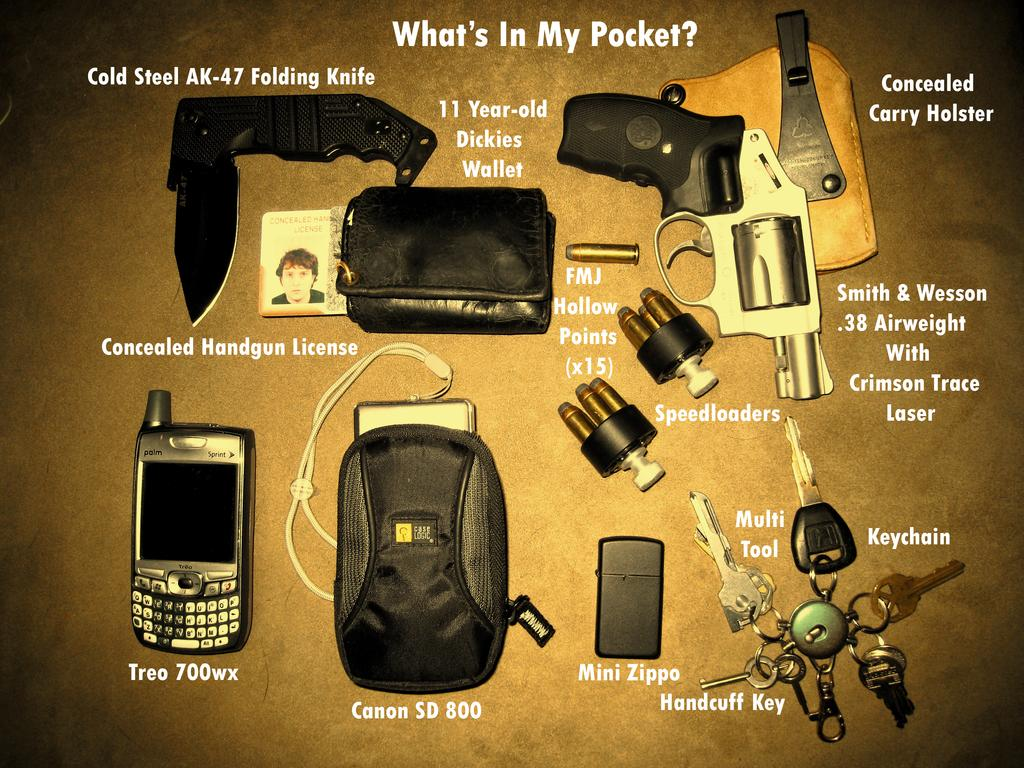<image>
Write a terse but informative summary of the picture. A poster with the title What's in My pocket shows a pocket knife, gun, ammo, holster, lighter, keys, wallet, and an electronic device. 